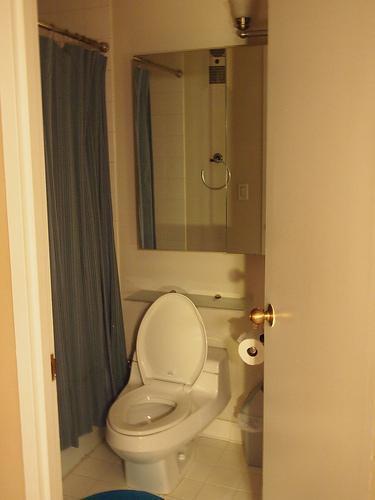How many toilets are shown?
Give a very brief answer. 1. 